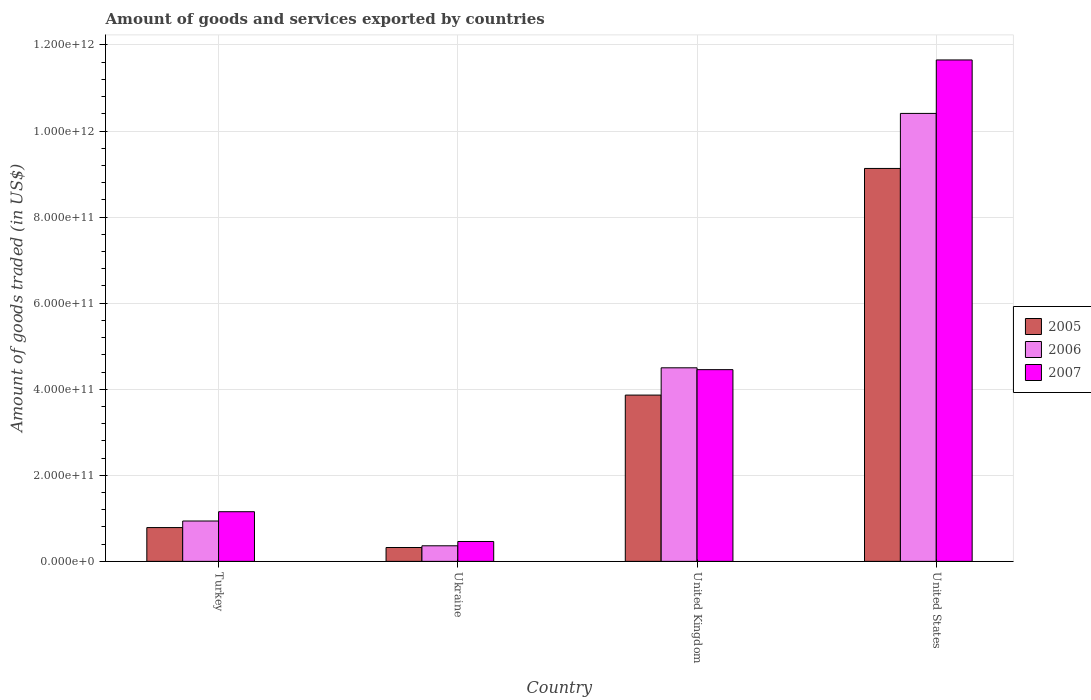How many groups of bars are there?
Provide a succinct answer. 4. How many bars are there on the 2nd tick from the right?
Give a very brief answer. 3. What is the label of the 3rd group of bars from the left?
Offer a terse response. United Kingdom. In how many cases, is the number of bars for a given country not equal to the number of legend labels?
Your response must be concise. 0. What is the total amount of goods and services exported in 2007 in Ukraine?
Your answer should be very brief. 4.62e+1. Across all countries, what is the maximum total amount of goods and services exported in 2007?
Your answer should be compact. 1.17e+12. Across all countries, what is the minimum total amount of goods and services exported in 2006?
Your answer should be compact. 3.62e+1. In which country was the total amount of goods and services exported in 2007 maximum?
Your answer should be very brief. United States. In which country was the total amount of goods and services exported in 2005 minimum?
Offer a very short reply. Ukraine. What is the total total amount of goods and services exported in 2005 in the graph?
Give a very brief answer. 1.41e+12. What is the difference between the total amount of goods and services exported in 2007 in United Kingdom and that in United States?
Keep it short and to the point. -7.20e+11. What is the difference between the total amount of goods and services exported in 2007 in United Kingdom and the total amount of goods and services exported in 2006 in Turkey?
Your answer should be compact. 3.52e+11. What is the average total amount of goods and services exported in 2007 per country?
Provide a short and direct response. 4.43e+11. What is the difference between the total amount of goods and services exported of/in 2007 and total amount of goods and services exported of/in 2006 in United States?
Your answer should be compact. 1.24e+11. What is the ratio of the total amount of goods and services exported in 2006 in Ukraine to that in United States?
Your answer should be very brief. 0.03. What is the difference between the highest and the second highest total amount of goods and services exported in 2005?
Provide a succinct answer. 8.35e+11. What is the difference between the highest and the lowest total amount of goods and services exported in 2006?
Ensure brevity in your answer.  1.00e+12. Is the sum of the total amount of goods and services exported in 2006 in Ukraine and United Kingdom greater than the maximum total amount of goods and services exported in 2007 across all countries?
Ensure brevity in your answer.  No. What does the 3rd bar from the left in United States represents?
Keep it short and to the point. 2007. What does the 1st bar from the right in Ukraine represents?
Your answer should be compact. 2007. Is it the case that in every country, the sum of the total amount of goods and services exported in 2007 and total amount of goods and services exported in 2005 is greater than the total amount of goods and services exported in 2006?
Your answer should be very brief. Yes. How many bars are there?
Ensure brevity in your answer.  12. What is the difference between two consecutive major ticks on the Y-axis?
Ensure brevity in your answer.  2.00e+11. Are the values on the major ticks of Y-axis written in scientific E-notation?
Provide a succinct answer. Yes. Does the graph contain any zero values?
Make the answer very short. No. How are the legend labels stacked?
Ensure brevity in your answer.  Vertical. What is the title of the graph?
Provide a short and direct response. Amount of goods and services exported by countries. What is the label or title of the Y-axis?
Make the answer very short. Amount of goods traded (in US$). What is the Amount of goods traded (in US$) in 2005 in Turkey?
Make the answer very short. 7.85e+1. What is the Amount of goods traded (in US$) in 2006 in Turkey?
Keep it short and to the point. 9.38e+1. What is the Amount of goods traded (in US$) of 2007 in Turkey?
Your response must be concise. 1.15e+11. What is the Amount of goods traded (in US$) in 2005 in Ukraine?
Keep it short and to the point. 3.22e+1. What is the Amount of goods traded (in US$) of 2006 in Ukraine?
Offer a terse response. 3.62e+1. What is the Amount of goods traded (in US$) in 2007 in Ukraine?
Offer a very short reply. 4.62e+1. What is the Amount of goods traded (in US$) in 2005 in United Kingdom?
Provide a succinct answer. 3.86e+11. What is the Amount of goods traded (in US$) of 2006 in United Kingdom?
Give a very brief answer. 4.50e+11. What is the Amount of goods traded (in US$) of 2007 in United Kingdom?
Your response must be concise. 4.45e+11. What is the Amount of goods traded (in US$) in 2005 in United States?
Your answer should be compact. 9.13e+11. What is the Amount of goods traded (in US$) in 2006 in United States?
Ensure brevity in your answer.  1.04e+12. What is the Amount of goods traded (in US$) of 2007 in United States?
Make the answer very short. 1.17e+12. Across all countries, what is the maximum Amount of goods traded (in US$) in 2005?
Your response must be concise. 9.13e+11. Across all countries, what is the maximum Amount of goods traded (in US$) of 2006?
Make the answer very short. 1.04e+12. Across all countries, what is the maximum Amount of goods traded (in US$) of 2007?
Your response must be concise. 1.17e+12. Across all countries, what is the minimum Amount of goods traded (in US$) in 2005?
Ensure brevity in your answer.  3.22e+1. Across all countries, what is the minimum Amount of goods traded (in US$) in 2006?
Offer a very short reply. 3.62e+1. Across all countries, what is the minimum Amount of goods traded (in US$) in 2007?
Offer a very short reply. 4.62e+1. What is the total Amount of goods traded (in US$) in 2005 in the graph?
Provide a short and direct response. 1.41e+12. What is the total Amount of goods traded (in US$) of 2006 in the graph?
Ensure brevity in your answer.  1.62e+12. What is the total Amount of goods traded (in US$) in 2007 in the graph?
Ensure brevity in your answer.  1.77e+12. What is the difference between the Amount of goods traded (in US$) of 2005 in Turkey and that in Ukraine?
Offer a terse response. 4.63e+1. What is the difference between the Amount of goods traded (in US$) of 2006 in Turkey and that in Ukraine?
Offer a terse response. 5.76e+1. What is the difference between the Amount of goods traded (in US$) of 2007 in Turkey and that in Ukraine?
Keep it short and to the point. 6.92e+1. What is the difference between the Amount of goods traded (in US$) in 2005 in Turkey and that in United Kingdom?
Keep it short and to the point. -3.08e+11. What is the difference between the Amount of goods traded (in US$) in 2006 in Turkey and that in United Kingdom?
Provide a short and direct response. -3.56e+11. What is the difference between the Amount of goods traded (in US$) in 2007 in Turkey and that in United Kingdom?
Your response must be concise. -3.30e+11. What is the difference between the Amount of goods traded (in US$) of 2005 in Turkey and that in United States?
Provide a succinct answer. -8.35e+11. What is the difference between the Amount of goods traded (in US$) of 2006 in Turkey and that in United States?
Ensure brevity in your answer.  -9.47e+11. What is the difference between the Amount of goods traded (in US$) of 2007 in Turkey and that in United States?
Your answer should be compact. -1.05e+12. What is the difference between the Amount of goods traded (in US$) in 2005 in Ukraine and that in United Kingdom?
Offer a terse response. -3.54e+11. What is the difference between the Amount of goods traded (in US$) of 2006 in Ukraine and that in United Kingdom?
Provide a succinct answer. -4.14e+11. What is the difference between the Amount of goods traded (in US$) in 2007 in Ukraine and that in United Kingdom?
Your answer should be compact. -3.99e+11. What is the difference between the Amount of goods traded (in US$) of 2005 in Ukraine and that in United States?
Keep it short and to the point. -8.81e+11. What is the difference between the Amount of goods traded (in US$) in 2006 in Ukraine and that in United States?
Give a very brief answer. -1.00e+12. What is the difference between the Amount of goods traded (in US$) in 2007 in Ukraine and that in United States?
Offer a very short reply. -1.12e+12. What is the difference between the Amount of goods traded (in US$) of 2005 in United Kingdom and that in United States?
Ensure brevity in your answer.  -5.27e+11. What is the difference between the Amount of goods traded (in US$) of 2006 in United Kingdom and that in United States?
Make the answer very short. -5.91e+11. What is the difference between the Amount of goods traded (in US$) of 2007 in United Kingdom and that in United States?
Offer a terse response. -7.20e+11. What is the difference between the Amount of goods traded (in US$) of 2005 in Turkey and the Amount of goods traded (in US$) of 2006 in Ukraine?
Ensure brevity in your answer.  4.23e+1. What is the difference between the Amount of goods traded (in US$) of 2005 in Turkey and the Amount of goods traded (in US$) of 2007 in Ukraine?
Provide a short and direct response. 3.23e+1. What is the difference between the Amount of goods traded (in US$) of 2006 in Turkey and the Amount of goods traded (in US$) of 2007 in Ukraine?
Make the answer very short. 4.76e+1. What is the difference between the Amount of goods traded (in US$) of 2005 in Turkey and the Amount of goods traded (in US$) of 2006 in United Kingdom?
Your response must be concise. -3.71e+11. What is the difference between the Amount of goods traded (in US$) of 2005 in Turkey and the Amount of goods traded (in US$) of 2007 in United Kingdom?
Your answer should be very brief. -3.67e+11. What is the difference between the Amount of goods traded (in US$) in 2006 in Turkey and the Amount of goods traded (in US$) in 2007 in United Kingdom?
Your answer should be very brief. -3.52e+11. What is the difference between the Amount of goods traded (in US$) in 2005 in Turkey and the Amount of goods traded (in US$) in 2006 in United States?
Your answer should be compact. -9.62e+11. What is the difference between the Amount of goods traded (in US$) in 2005 in Turkey and the Amount of goods traded (in US$) in 2007 in United States?
Offer a very short reply. -1.09e+12. What is the difference between the Amount of goods traded (in US$) in 2006 in Turkey and the Amount of goods traded (in US$) in 2007 in United States?
Ensure brevity in your answer.  -1.07e+12. What is the difference between the Amount of goods traded (in US$) of 2005 in Ukraine and the Amount of goods traded (in US$) of 2006 in United Kingdom?
Make the answer very short. -4.18e+11. What is the difference between the Amount of goods traded (in US$) in 2005 in Ukraine and the Amount of goods traded (in US$) in 2007 in United Kingdom?
Your answer should be compact. -4.13e+11. What is the difference between the Amount of goods traded (in US$) in 2006 in Ukraine and the Amount of goods traded (in US$) in 2007 in United Kingdom?
Offer a terse response. -4.09e+11. What is the difference between the Amount of goods traded (in US$) of 2005 in Ukraine and the Amount of goods traded (in US$) of 2006 in United States?
Give a very brief answer. -1.01e+12. What is the difference between the Amount of goods traded (in US$) in 2005 in Ukraine and the Amount of goods traded (in US$) in 2007 in United States?
Give a very brief answer. -1.13e+12. What is the difference between the Amount of goods traded (in US$) of 2006 in Ukraine and the Amount of goods traded (in US$) of 2007 in United States?
Make the answer very short. -1.13e+12. What is the difference between the Amount of goods traded (in US$) of 2005 in United Kingdom and the Amount of goods traded (in US$) of 2006 in United States?
Make the answer very short. -6.55e+11. What is the difference between the Amount of goods traded (in US$) of 2005 in United Kingdom and the Amount of goods traded (in US$) of 2007 in United States?
Make the answer very short. -7.79e+11. What is the difference between the Amount of goods traded (in US$) in 2006 in United Kingdom and the Amount of goods traded (in US$) in 2007 in United States?
Keep it short and to the point. -7.15e+11. What is the average Amount of goods traded (in US$) in 2005 per country?
Provide a succinct answer. 3.53e+11. What is the average Amount of goods traded (in US$) of 2006 per country?
Ensure brevity in your answer.  4.05e+11. What is the average Amount of goods traded (in US$) of 2007 per country?
Your answer should be compact. 4.43e+11. What is the difference between the Amount of goods traded (in US$) in 2005 and Amount of goods traded (in US$) in 2006 in Turkey?
Ensure brevity in your answer.  -1.53e+1. What is the difference between the Amount of goods traded (in US$) of 2005 and Amount of goods traded (in US$) of 2007 in Turkey?
Your answer should be very brief. -3.69e+1. What is the difference between the Amount of goods traded (in US$) of 2006 and Amount of goods traded (in US$) of 2007 in Turkey?
Make the answer very short. -2.16e+1. What is the difference between the Amount of goods traded (in US$) of 2005 and Amount of goods traded (in US$) of 2006 in Ukraine?
Your answer should be very brief. -3.99e+09. What is the difference between the Amount of goods traded (in US$) in 2005 and Amount of goods traded (in US$) in 2007 in Ukraine?
Offer a very short reply. -1.40e+1. What is the difference between the Amount of goods traded (in US$) of 2006 and Amount of goods traded (in US$) of 2007 in Ukraine?
Your answer should be compact. -9.99e+09. What is the difference between the Amount of goods traded (in US$) in 2005 and Amount of goods traded (in US$) in 2006 in United Kingdom?
Make the answer very short. -6.34e+1. What is the difference between the Amount of goods traded (in US$) in 2005 and Amount of goods traded (in US$) in 2007 in United Kingdom?
Your answer should be compact. -5.91e+1. What is the difference between the Amount of goods traded (in US$) of 2006 and Amount of goods traded (in US$) of 2007 in United Kingdom?
Ensure brevity in your answer.  4.31e+09. What is the difference between the Amount of goods traded (in US$) in 2005 and Amount of goods traded (in US$) in 2006 in United States?
Keep it short and to the point. -1.28e+11. What is the difference between the Amount of goods traded (in US$) in 2005 and Amount of goods traded (in US$) in 2007 in United States?
Your response must be concise. -2.52e+11. What is the difference between the Amount of goods traded (in US$) of 2006 and Amount of goods traded (in US$) of 2007 in United States?
Your response must be concise. -1.24e+11. What is the ratio of the Amount of goods traded (in US$) in 2005 in Turkey to that in Ukraine?
Provide a succinct answer. 2.44. What is the ratio of the Amount of goods traded (in US$) in 2006 in Turkey to that in Ukraine?
Your answer should be very brief. 2.59. What is the ratio of the Amount of goods traded (in US$) in 2007 in Turkey to that in Ukraine?
Offer a terse response. 2.5. What is the ratio of the Amount of goods traded (in US$) in 2005 in Turkey to that in United Kingdom?
Provide a succinct answer. 0.2. What is the ratio of the Amount of goods traded (in US$) in 2006 in Turkey to that in United Kingdom?
Make the answer very short. 0.21. What is the ratio of the Amount of goods traded (in US$) of 2007 in Turkey to that in United Kingdom?
Offer a very short reply. 0.26. What is the ratio of the Amount of goods traded (in US$) of 2005 in Turkey to that in United States?
Keep it short and to the point. 0.09. What is the ratio of the Amount of goods traded (in US$) in 2006 in Turkey to that in United States?
Keep it short and to the point. 0.09. What is the ratio of the Amount of goods traded (in US$) of 2007 in Turkey to that in United States?
Provide a short and direct response. 0.1. What is the ratio of the Amount of goods traded (in US$) of 2005 in Ukraine to that in United Kingdom?
Ensure brevity in your answer.  0.08. What is the ratio of the Amount of goods traded (in US$) of 2006 in Ukraine to that in United Kingdom?
Your response must be concise. 0.08. What is the ratio of the Amount of goods traded (in US$) in 2007 in Ukraine to that in United Kingdom?
Keep it short and to the point. 0.1. What is the ratio of the Amount of goods traded (in US$) of 2005 in Ukraine to that in United States?
Ensure brevity in your answer.  0.04. What is the ratio of the Amount of goods traded (in US$) of 2006 in Ukraine to that in United States?
Give a very brief answer. 0.03. What is the ratio of the Amount of goods traded (in US$) in 2007 in Ukraine to that in United States?
Provide a succinct answer. 0.04. What is the ratio of the Amount of goods traded (in US$) of 2005 in United Kingdom to that in United States?
Ensure brevity in your answer.  0.42. What is the ratio of the Amount of goods traded (in US$) in 2006 in United Kingdom to that in United States?
Offer a terse response. 0.43. What is the ratio of the Amount of goods traded (in US$) of 2007 in United Kingdom to that in United States?
Make the answer very short. 0.38. What is the difference between the highest and the second highest Amount of goods traded (in US$) in 2005?
Offer a terse response. 5.27e+11. What is the difference between the highest and the second highest Amount of goods traded (in US$) of 2006?
Your answer should be very brief. 5.91e+11. What is the difference between the highest and the second highest Amount of goods traded (in US$) of 2007?
Make the answer very short. 7.20e+11. What is the difference between the highest and the lowest Amount of goods traded (in US$) in 2005?
Offer a very short reply. 8.81e+11. What is the difference between the highest and the lowest Amount of goods traded (in US$) in 2006?
Keep it short and to the point. 1.00e+12. What is the difference between the highest and the lowest Amount of goods traded (in US$) in 2007?
Provide a short and direct response. 1.12e+12. 